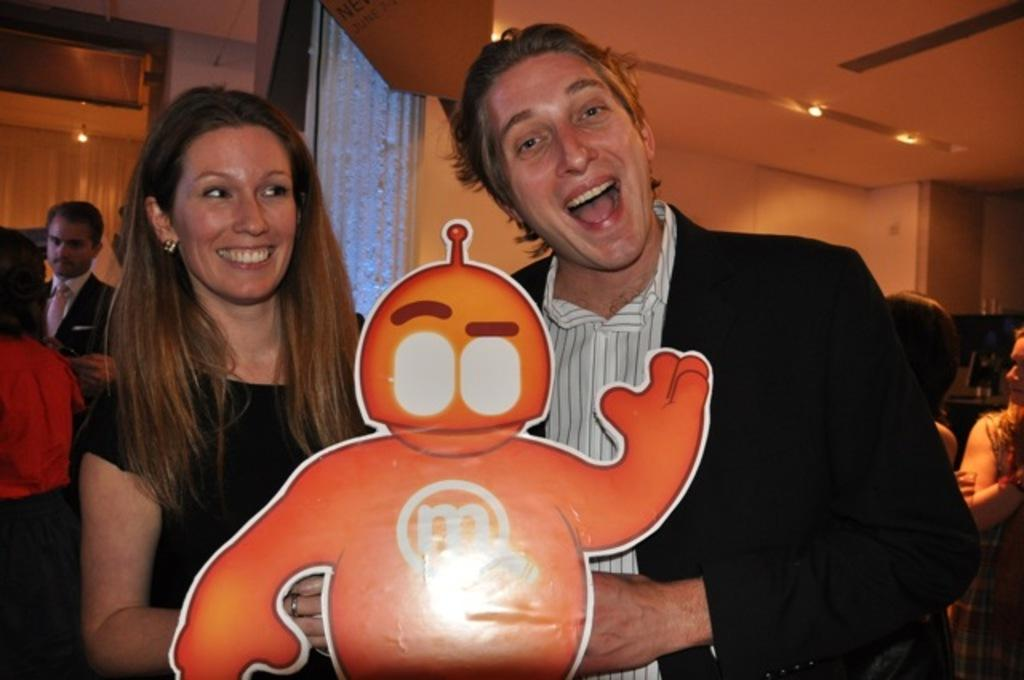How many people are in the image? There is a group of people in the image, but the exact number cannot be determined from the provided facts. What is the position of the people in the image? The people are standing on the floor in the image. What can be seen in the background of the image? There is a wall and lights in the background of the image. Can you suggest a possible location for the image based on the background? The image may have been taken in a restaurant, given the presence of a wall and lights. What type of tin can be seen on the floor in the image? There is no tin present on the floor in the image. What shape is the cloud in the image? There is no cloud present in the image. 